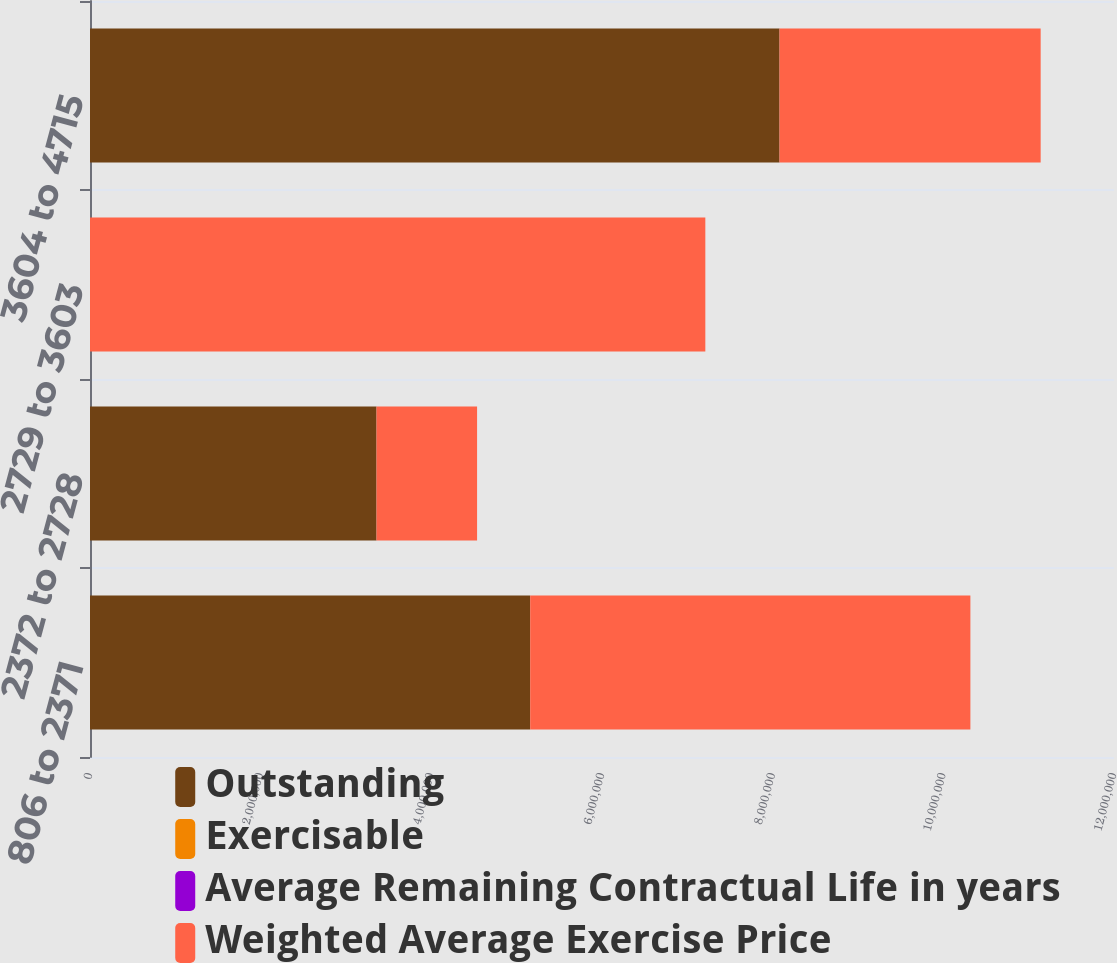<chart> <loc_0><loc_0><loc_500><loc_500><stacked_bar_chart><ecel><fcel>806 to 2371<fcel>2372 to 2728<fcel>2729 to 3603<fcel>3604 to 4715<nl><fcel>Outstanding<fcel>5.15855e+06<fcel>3.3577e+06<fcel>40.88<fcel>8.08032e+06<nl><fcel>Exercisable<fcel>13.62<fcel>25.71<fcel>30.95<fcel>40.88<nl><fcel>Average Remaining Contractual Life in years<fcel>2<fcel>7.7<fcel>6.2<fcel>7.8<nl><fcel>Weighted Average Exercise Price<fcel>5.15855e+06<fcel>1.1784e+06<fcel>7.21081e+06<fcel>3.06022e+06<nl></chart> 